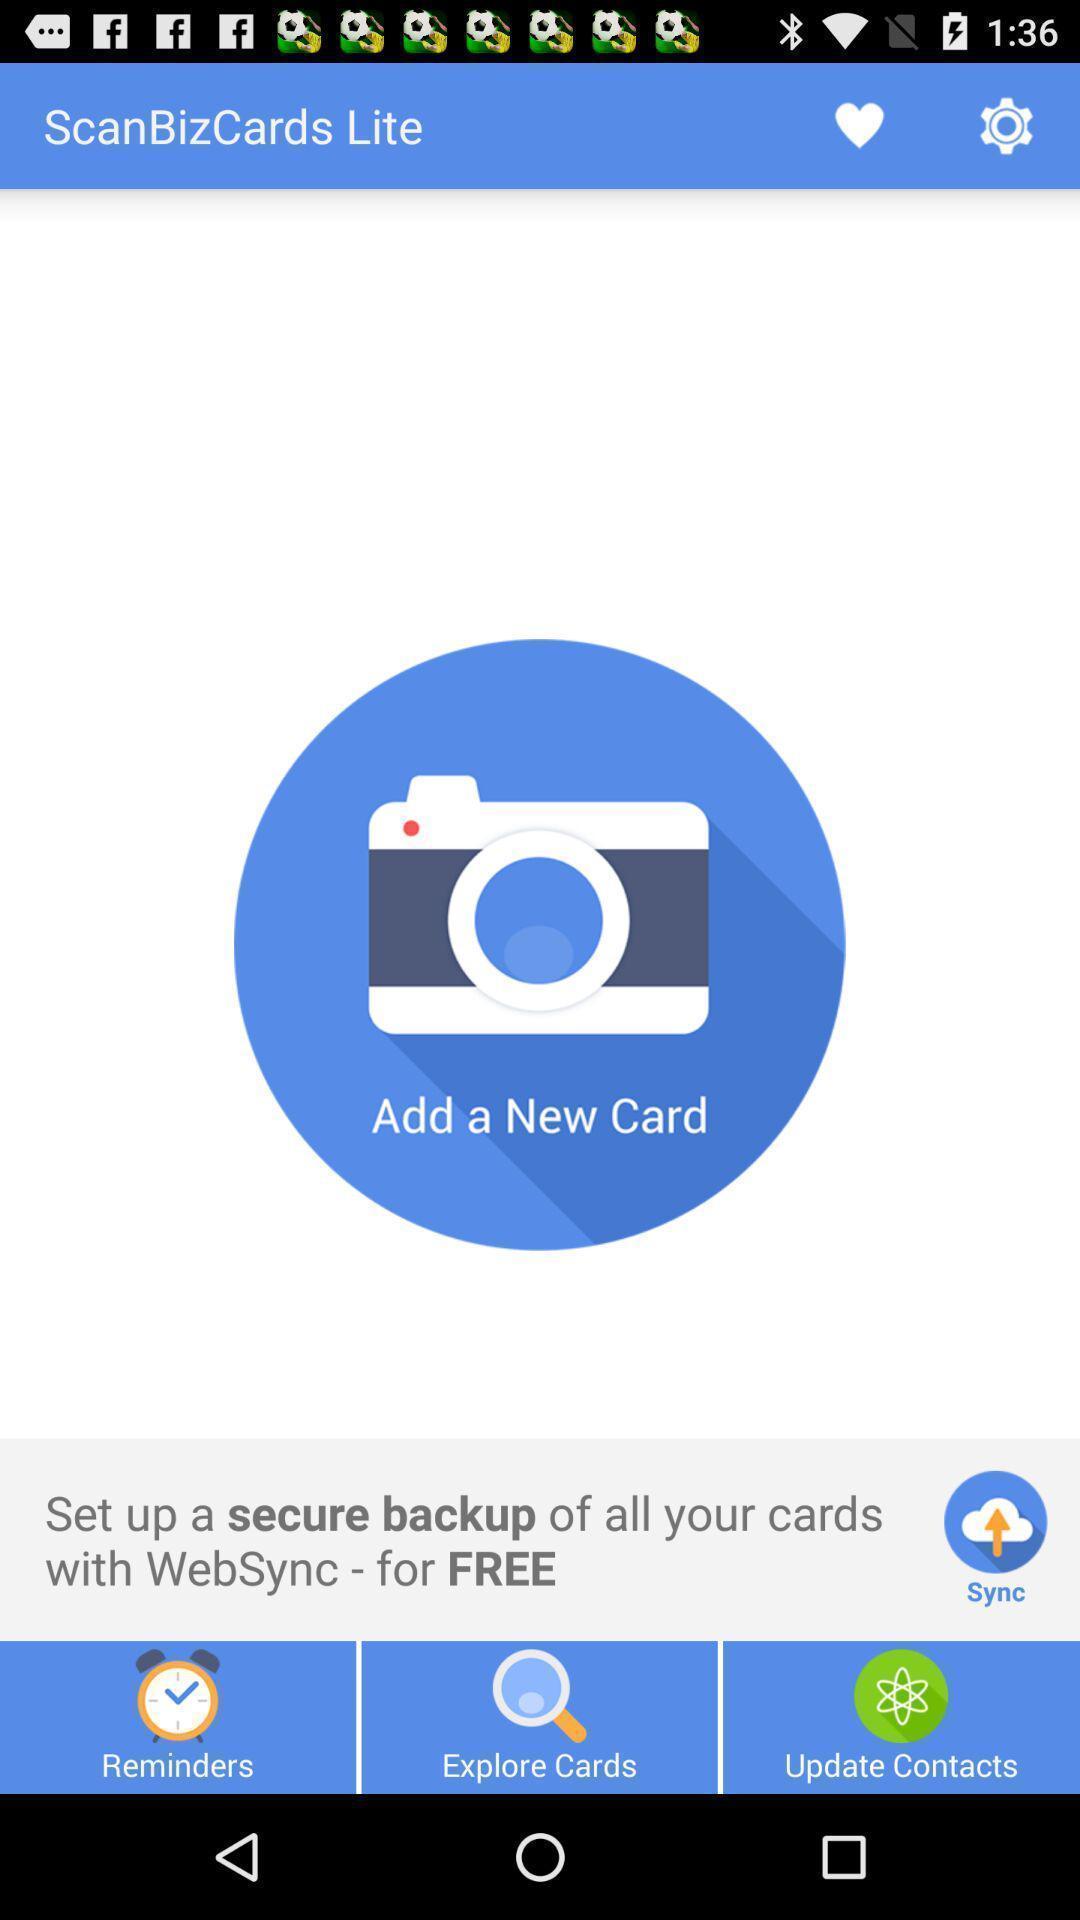Give me a narrative description of this picture. Settings option showing in this page. 